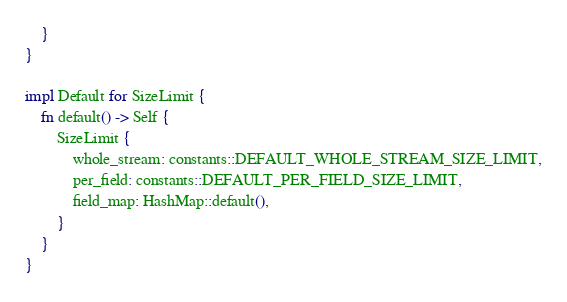<code> <loc_0><loc_0><loc_500><loc_500><_Rust_>    }
}

impl Default for SizeLimit {
    fn default() -> Self {
        SizeLimit {
            whole_stream: constants::DEFAULT_WHOLE_STREAM_SIZE_LIMIT,
            per_field: constants::DEFAULT_PER_FIELD_SIZE_LIMIT,
            field_map: HashMap::default(),
        }
    }
}
</code> 